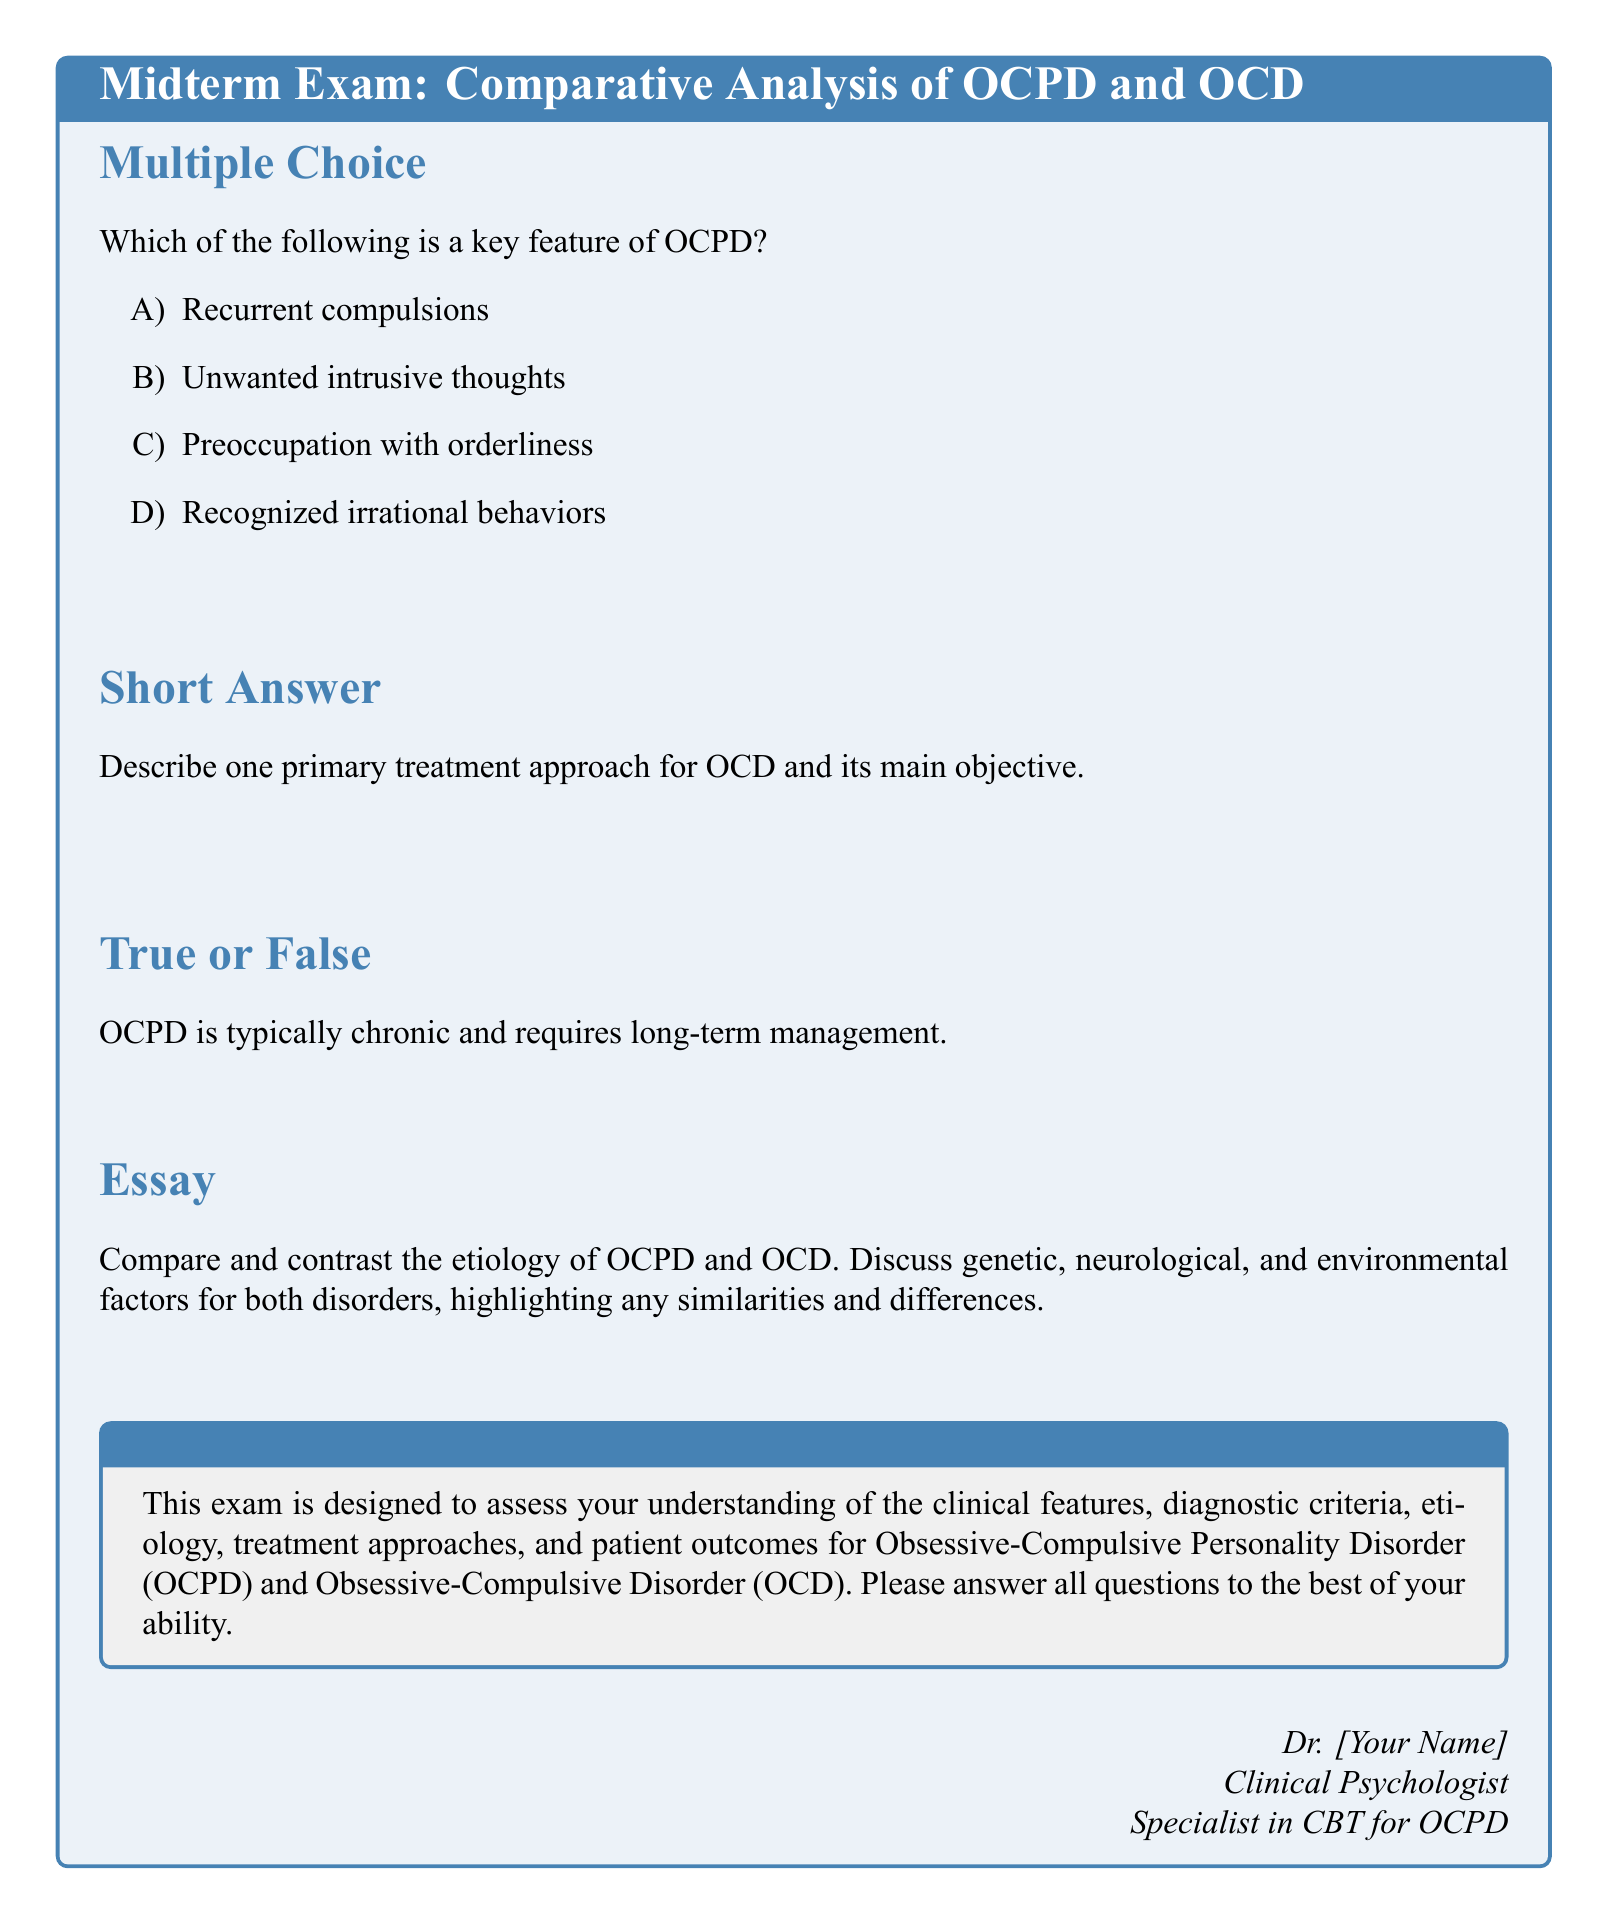What is the title of the document? The title is prominently displayed at the top of the document and is "Midterm Exam: Comparative Analysis of OCPD and OCD."
Answer: Midterm Exam: Comparative Analysis of OCPD and OCD What is the color of the box containing the multiple choice section? The multiple choice section is inside a tcolorbox with the color defined as myblue with a light shade.
Answer: myblue How many sections are in the exam? The document lists four distinct sections; therefore, the total number of sections is counted.
Answer: 4 What is one key feature of OCPD according to the multiple choice options? The document provides several choices in the multiple choice section, one of which directly highlights a feature of OCPD.
Answer: Preoccupation with orderliness What type of exam is this document? The document is structured as a midterm exam focused on a specific topic of psychological disorders.
Answer: midterm exam What does the essay section ask for? The essay section is requesting a comparison and contrast of specific factors related to two disorders, specifically OCPD and OCD.
Answer: Compare and contrast the etiology of OCPD and OCD Is OCPD typically chronic? There is a true or false statement in the document regarding the nature of OCPD, prompting confirmation or denial.
Answer: True What is the main objective of the primary treatment approach for OCD? The short answer section asks for a description of the treatment approach for OCD and its aim, prompting a focus on its objectives.
Answer: Reduce compulsions 